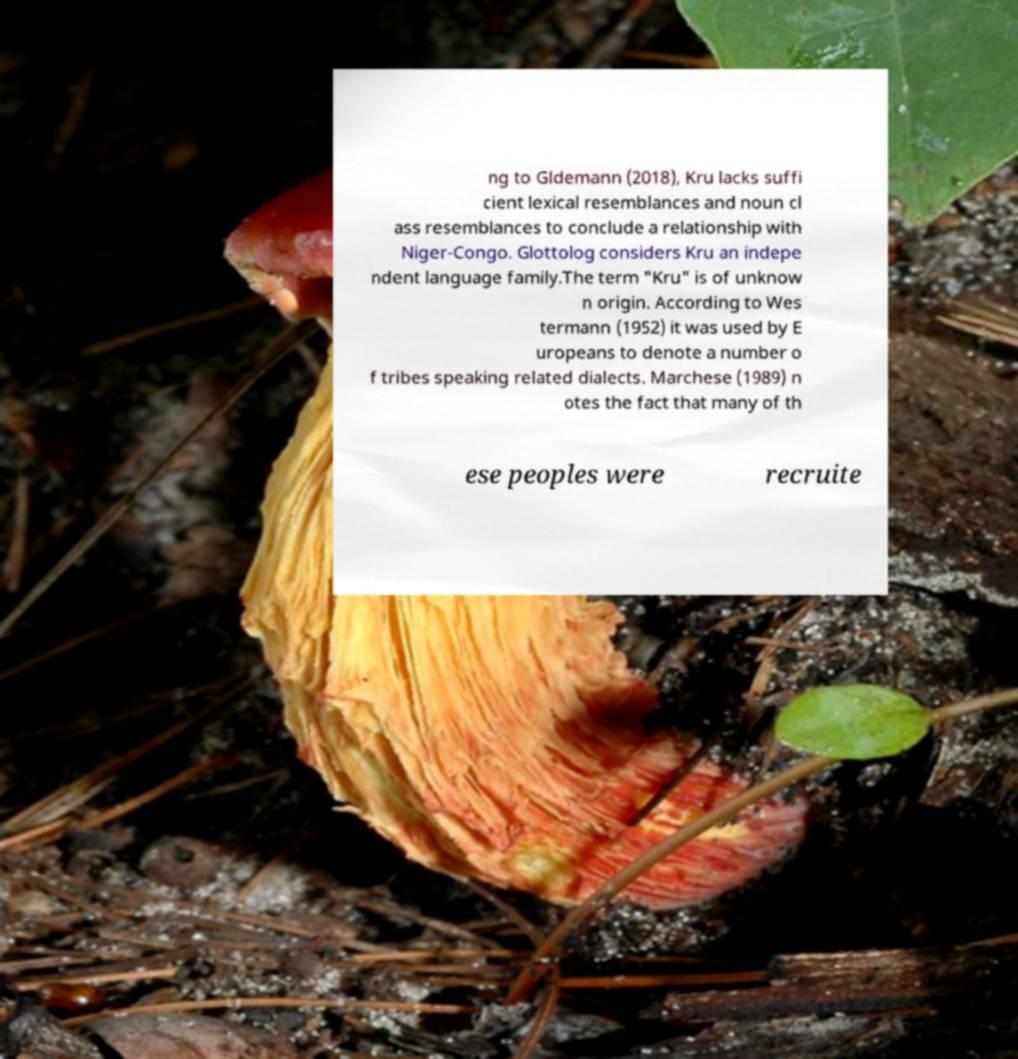Please read and relay the text visible in this image. What does it say? ng to Gldemann (2018), Kru lacks suffi cient lexical resemblances and noun cl ass resemblances to conclude a relationship with Niger-Congo. Glottolog considers Kru an indepe ndent language family.The term "Kru" is of unknow n origin. According to Wes termann (1952) it was used by E uropeans to denote a number o f tribes speaking related dialects. Marchese (1989) n otes the fact that many of th ese peoples were recruite 